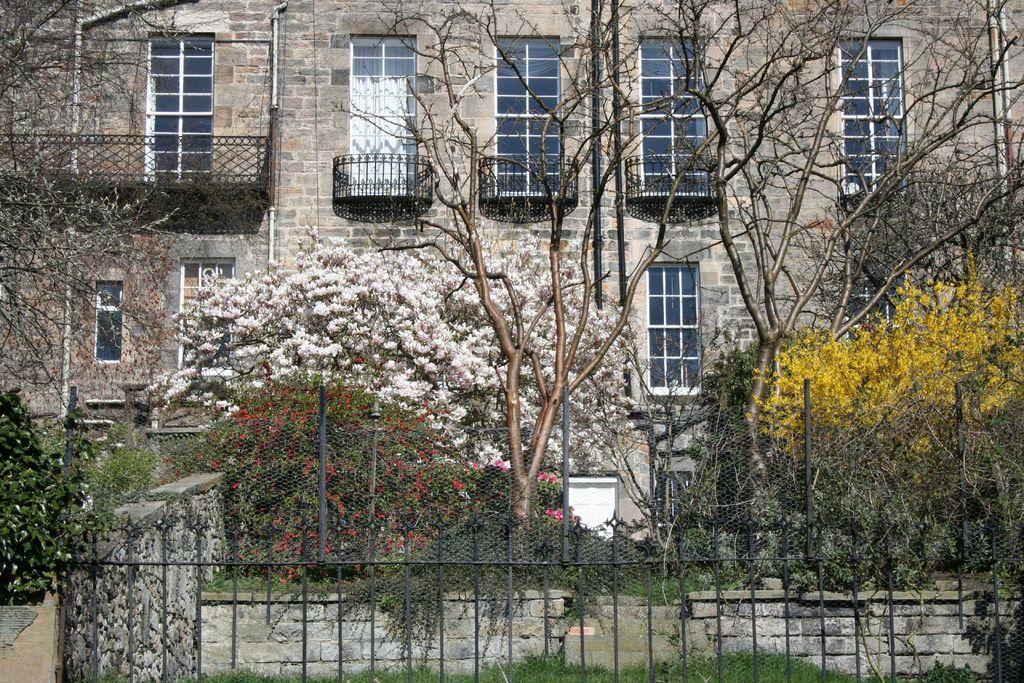In one or two sentences, can you explain what this image depicts? This image consists of a building along with windows. In the front, we can see many trees and plants. At the bottom, there is a fencing. 